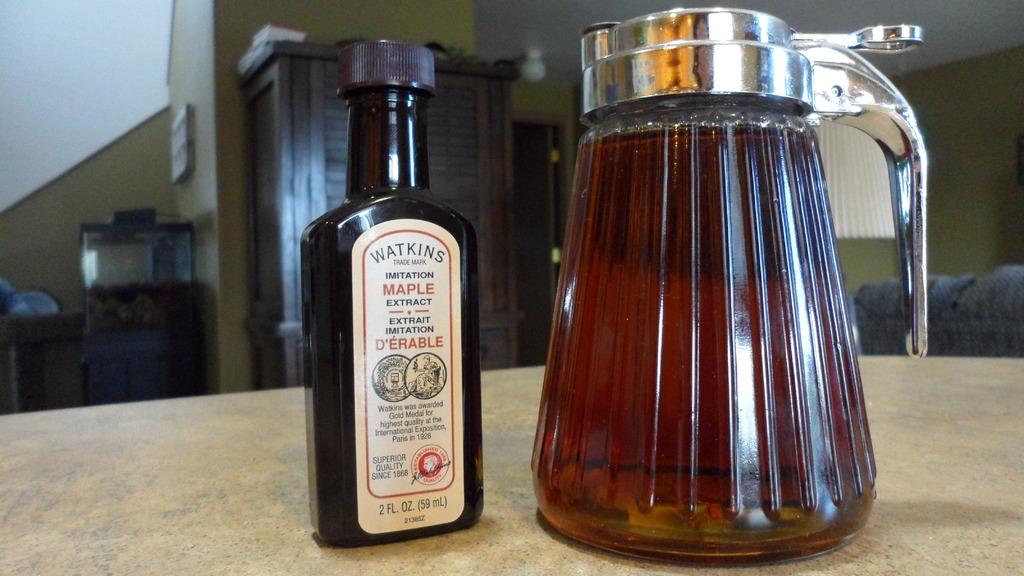Who makes this syrup?
Your answer should be compact. Watkins. What kind of syrup is it?
Make the answer very short. Maple. 